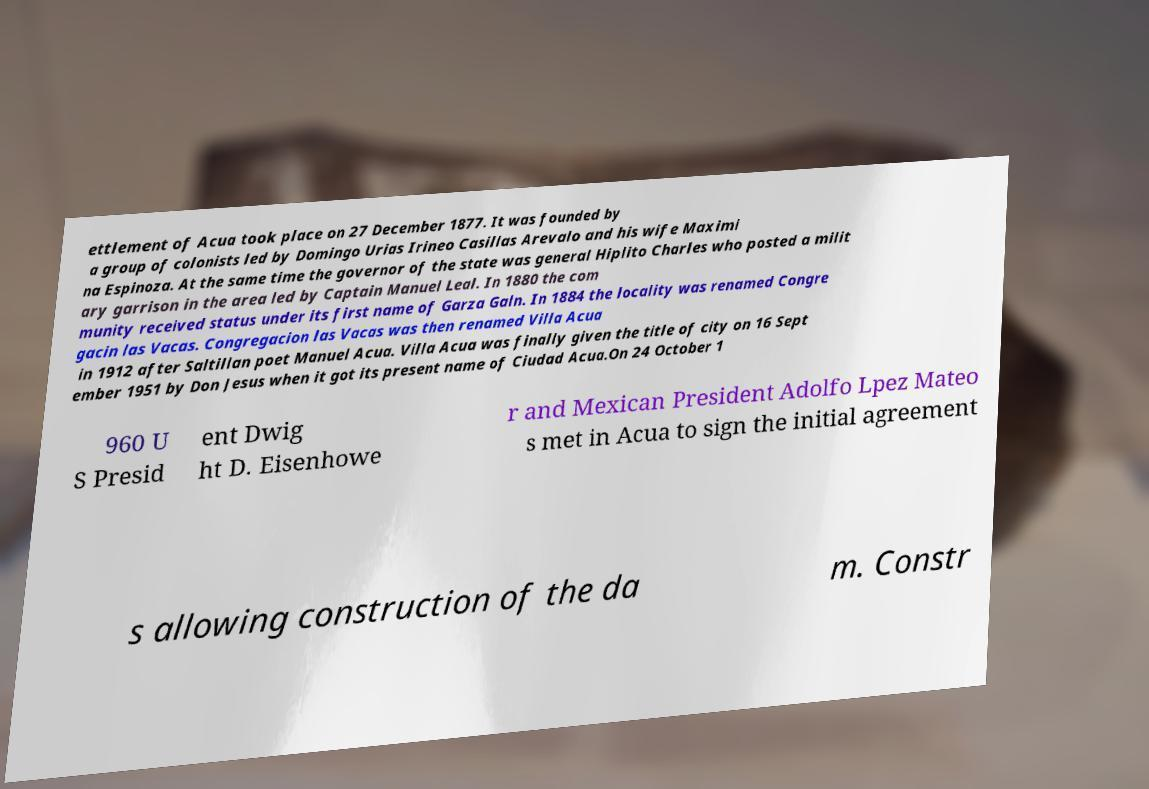Could you extract and type out the text from this image? ettlement of Acua took place on 27 December 1877. It was founded by a group of colonists led by Domingo Urias Irineo Casillas Arevalo and his wife Maximi na Espinoza. At the same time the governor of the state was general Hiplito Charles who posted a milit ary garrison in the area led by Captain Manuel Leal. In 1880 the com munity received status under its first name of Garza Galn. In 1884 the locality was renamed Congre gacin las Vacas. Congregacion las Vacas was then renamed Villa Acua in 1912 after Saltillan poet Manuel Acua. Villa Acua was finally given the title of city on 16 Sept ember 1951 by Don Jesus when it got its present name of Ciudad Acua.On 24 October 1 960 U S Presid ent Dwig ht D. Eisenhowe r and Mexican President Adolfo Lpez Mateo s met in Acua to sign the initial agreement s allowing construction of the da m. Constr 